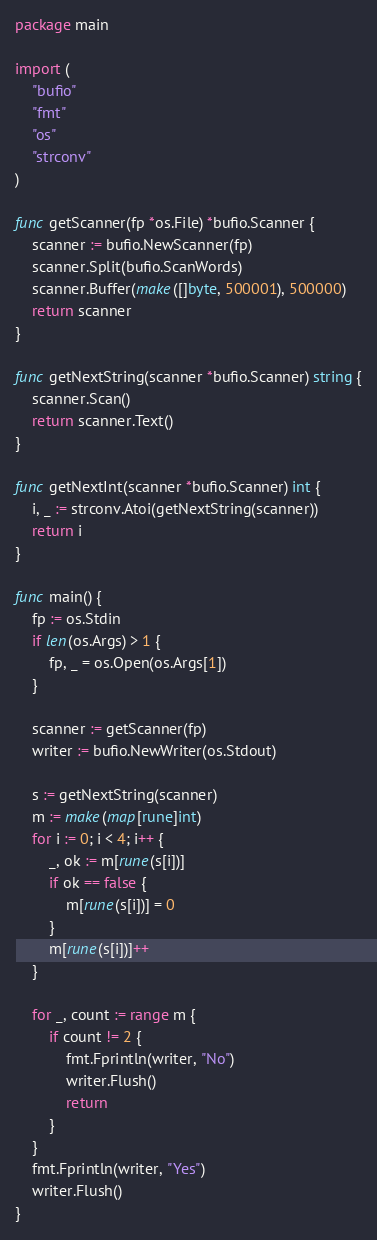Convert code to text. <code><loc_0><loc_0><loc_500><loc_500><_Go_>package main

import (
	"bufio"
	"fmt"
	"os"
	"strconv"
)

func getScanner(fp *os.File) *bufio.Scanner {
	scanner := bufio.NewScanner(fp)
	scanner.Split(bufio.ScanWords)
	scanner.Buffer(make([]byte, 500001), 500000)
	return scanner
}

func getNextString(scanner *bufio.Scanner) string {
	scanner.Scan()
	return scanner.Text()
}

func getNextInt(scanner *bufio.Scanner) int {
	i, _ := strconv.Atoi(getNextString(scanner))
	return i
}

func main() {
	fp := os.Stdin
	if len(os.Args) > 1 {
		fp, _ = os.Open(os.Args[1])
	}

	scanner := getScanner(fp)
	writer := bufio.NewWriter(os.Stdout)

	s := getNextString(scanner)
	m := make(map[rune]int)
	for i := 0; i < 4; i++ {
		_, ok := m[rune(s[i])]
		if ok == false {
			m[rune(s[i])] = 0
		}
		m[rune(s[i])]++
	}

	for _, count := range m {
		if count != 2 {
			fmt.Fprintln(writer, "No")
			writer.Flush()
			return
		}
	}
	fmt.Fprintln(writer, "Yes")
	writer.Flush()
}
</code> 